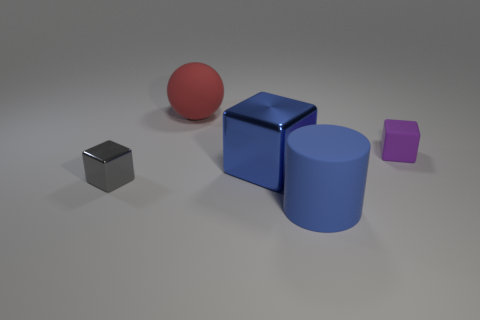Are there any reflections or shadows that indicate the light source in the image? Yes, there are subtle reflections on the metallic surfaces of the cubes and the cylinder, as well as shadows extending towards the lower right of the image. These clues suggest that the primary light source is to the upper left of the scene, out of frame. 